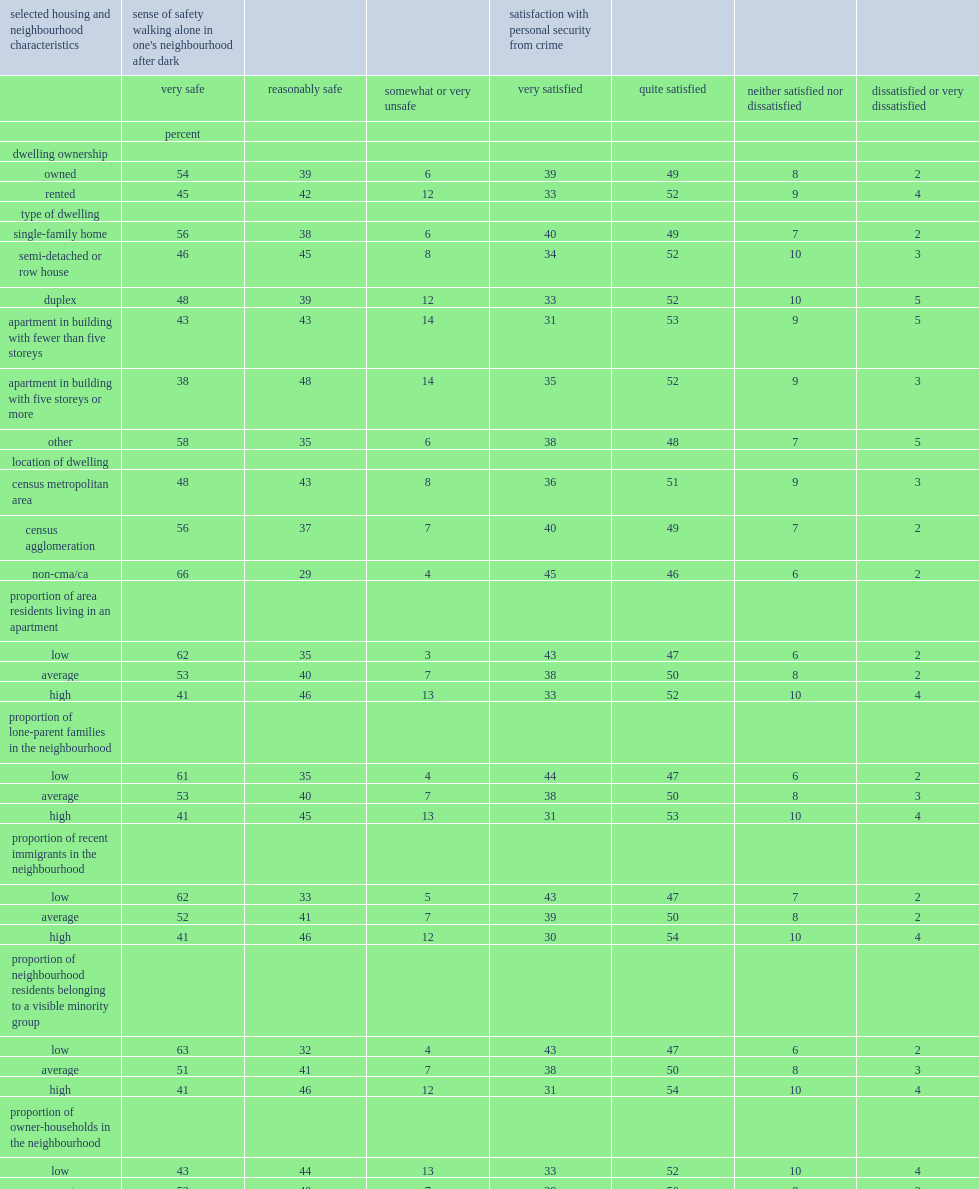Parse the table in full. {'header': ['selected housing and neighbourhood characteristics', "sense of safety walking alone in one's neighbourhood after dark", '', '', 'satisfaction with personal security from crime', '', '', ''], 'rows': [['', 'very safe', 'reasonably safe', 'somewhat or very unsafe', 'very satisfied', 'quite satisfied', 'neither satisfied nor dissatisfied', 'dissatisfied or very dissatisfied'], ['', 'percent', '', '', '', '', '', ''], ['dwelling ownership', '', '', '', '', '', '', ''], ['owned', '54', '39', '6', '39', '49', '8', '2'], ['rented', '45', '42', '12', '33', '52', '9', '4'], ['type of dwelling', '', '', '', '', '', '', ''], ['single-family home', '56', '38', '6', '40', '49', '7', '2'], ['semi-detached or row house', '46', '45', '8', '34', '52', '10', '3'], ['duplex', '48', '39', '12', '33', '52', '10', '5'], ['apartment in building with fewer than five storeys', '43', '43', '14', '31', '53', '9', '5'], ['apartment in building with five storeys or more', '38', '48', '14', '35', '52', '9', '3'], ['other', '58', '35', '6', '38', '48', '7', '5'], ['location of dwelling', '', '', '', '', '', '', ''], ['census metropolitan area', '48', '43', '8', '36', '51', '9', '3'], ['census agglomeration', '56', '37', '7', '40', '49', '7', '2'], ['non-cma/ca', '66', '29', '4', '45', '46', '6', '2'], ['proportion of area residents living in an apartment', '', '', '', '', '', '', ''], ['low', '62', '35', '3', '43', '47', '6', '2'], ['average', '53', '40', '7', '38', '50', '8', '2'], ['high', '41', '46', '13', '33', '52', '10', '4'], ['proportion of lone-parent families in the neighbourhood', '', '', '', '', '', '', ''], ['low', '61', '35', '4', '44', '47', '6', '2'], ['average', '53', '40', '7', '38', '50', '8', '3'], ['high', '41', '45', '13', '31', '53', '10', '4'], ['proportion of recent immigrants in the neighbourhood', '', '', '', '', '', '', ''], ['low', '62', '33', '5', '43', '47', '7', '2'], ['average', '52', '41', '7', '39', '50', '8', '2'], ['high', '41', '46', '12', '30', '54', '10', '4'], ['proportion of neighbourhood residents belonging to a visible minority group', '', '', '', '', '', '', ''], ['low', '63', '32', '4', '43', '47', '6', '2'], ['average', '51', '41', '7', '38', '50', '8', '3'], ['high', '41', '46', '12', '31', '54', '10', '4'], ['proportion of owner-households in the neighbourhood', '', '', '', '', '', '', ''], ['low', '43', '44', '13', '33', '52', '10', '4'], ['average', '53', '40', '7', '38', '50', '8', '3'], ['high', '59', '37', '4', '41', '49', '7', '2'], ['proportion of neighbourhood families living below the low-income threshold', '', '', '', '', '', '', ''], ['low', '58', '37', '5', '42', '48', '7', '2'], ['average', '52', '41', '6', '38', '50', '8', '3'], ['high', '44', '43', '13', '32', '52', '9', '4'], ['proportion of neighbourhood residents living at the same address as five years previously', '', '', '', '', '', '', ''], ['low', '44', '45', '11', '33', '53', '10', '4'], ['average', '52', '40', '8', '37', '50', '8', '3'], ['high', '60', '36', '4', '43', '48', '7', '2']]} Who were the least likely to report feeling very safe walking alone in their neighbourhood after dark? Apartment in building with five storeys or more. Who were less likely to say they felt very safe,people living in a neighbourhood where there is a high proportion of apartments or where the proportion was lower. High. 